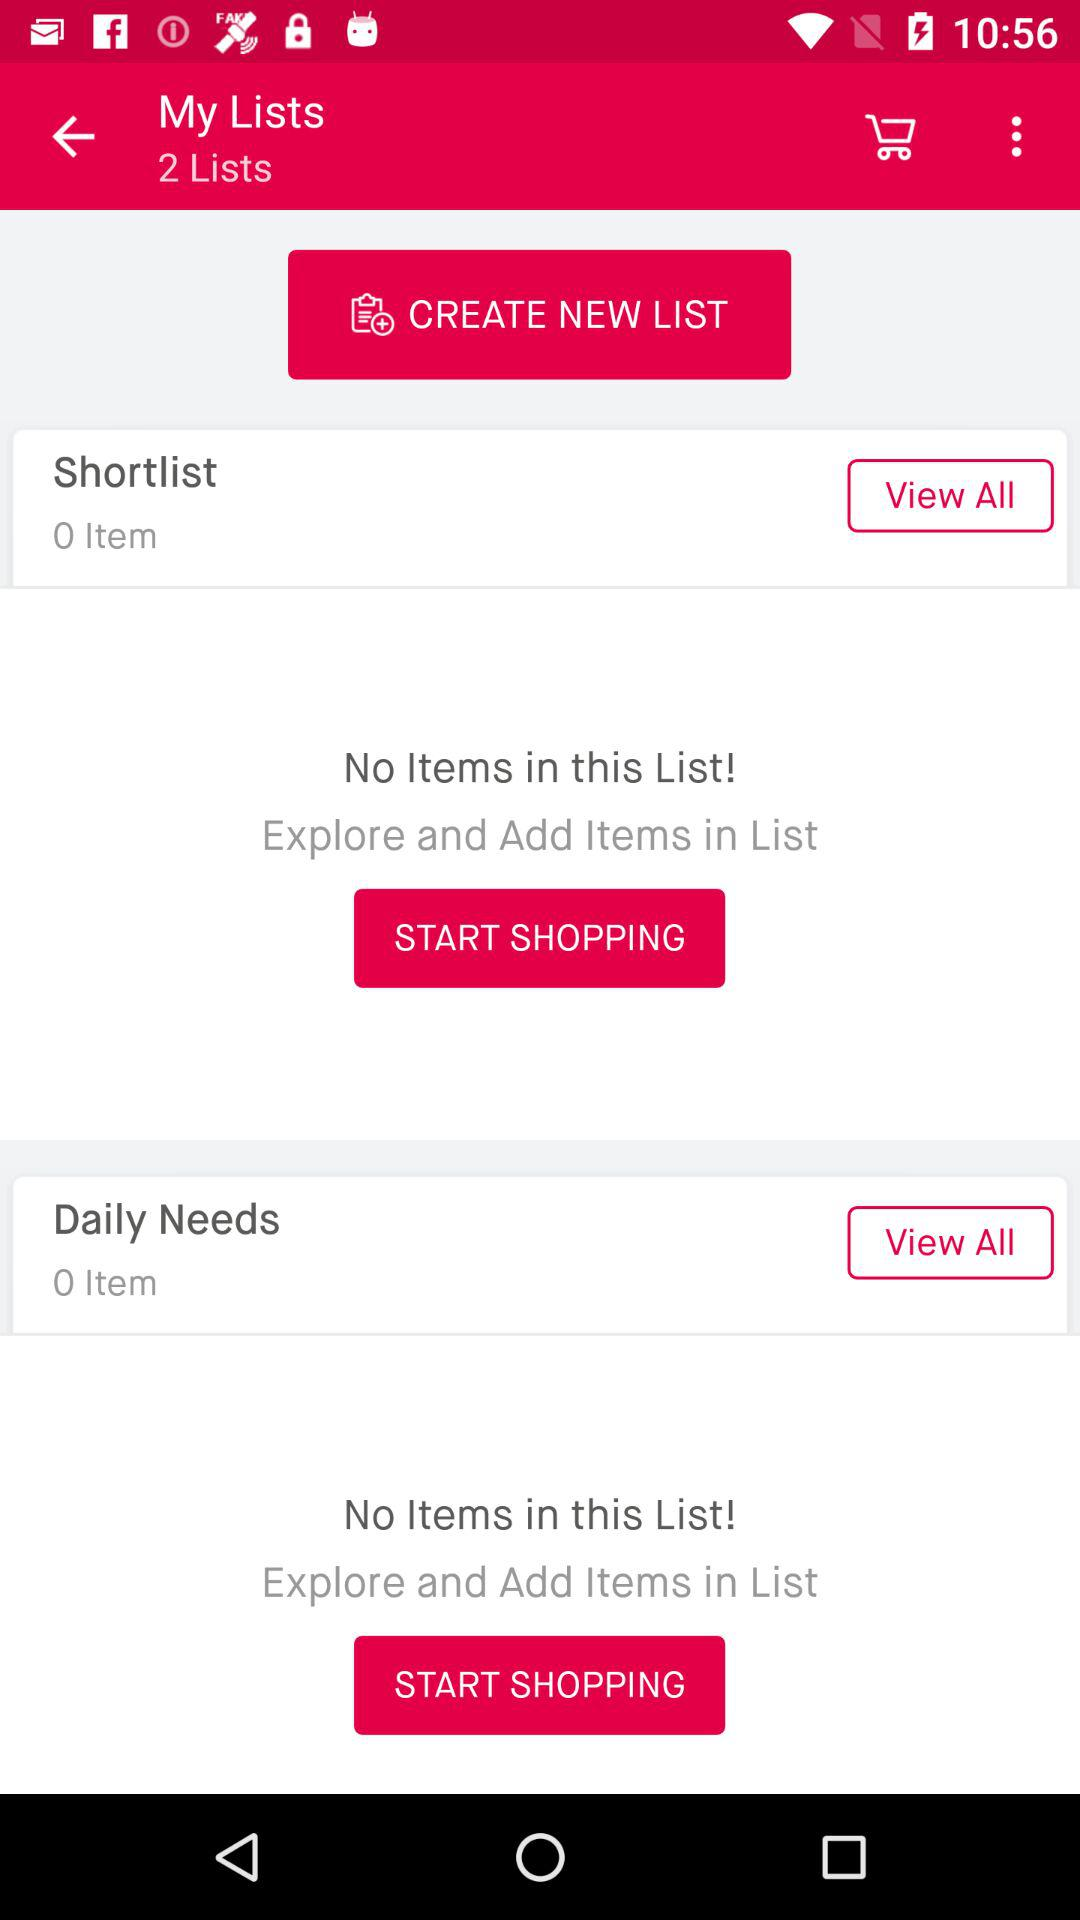How many items are there in the "Shortlist"? There is 0 item in the "Shortlist". 